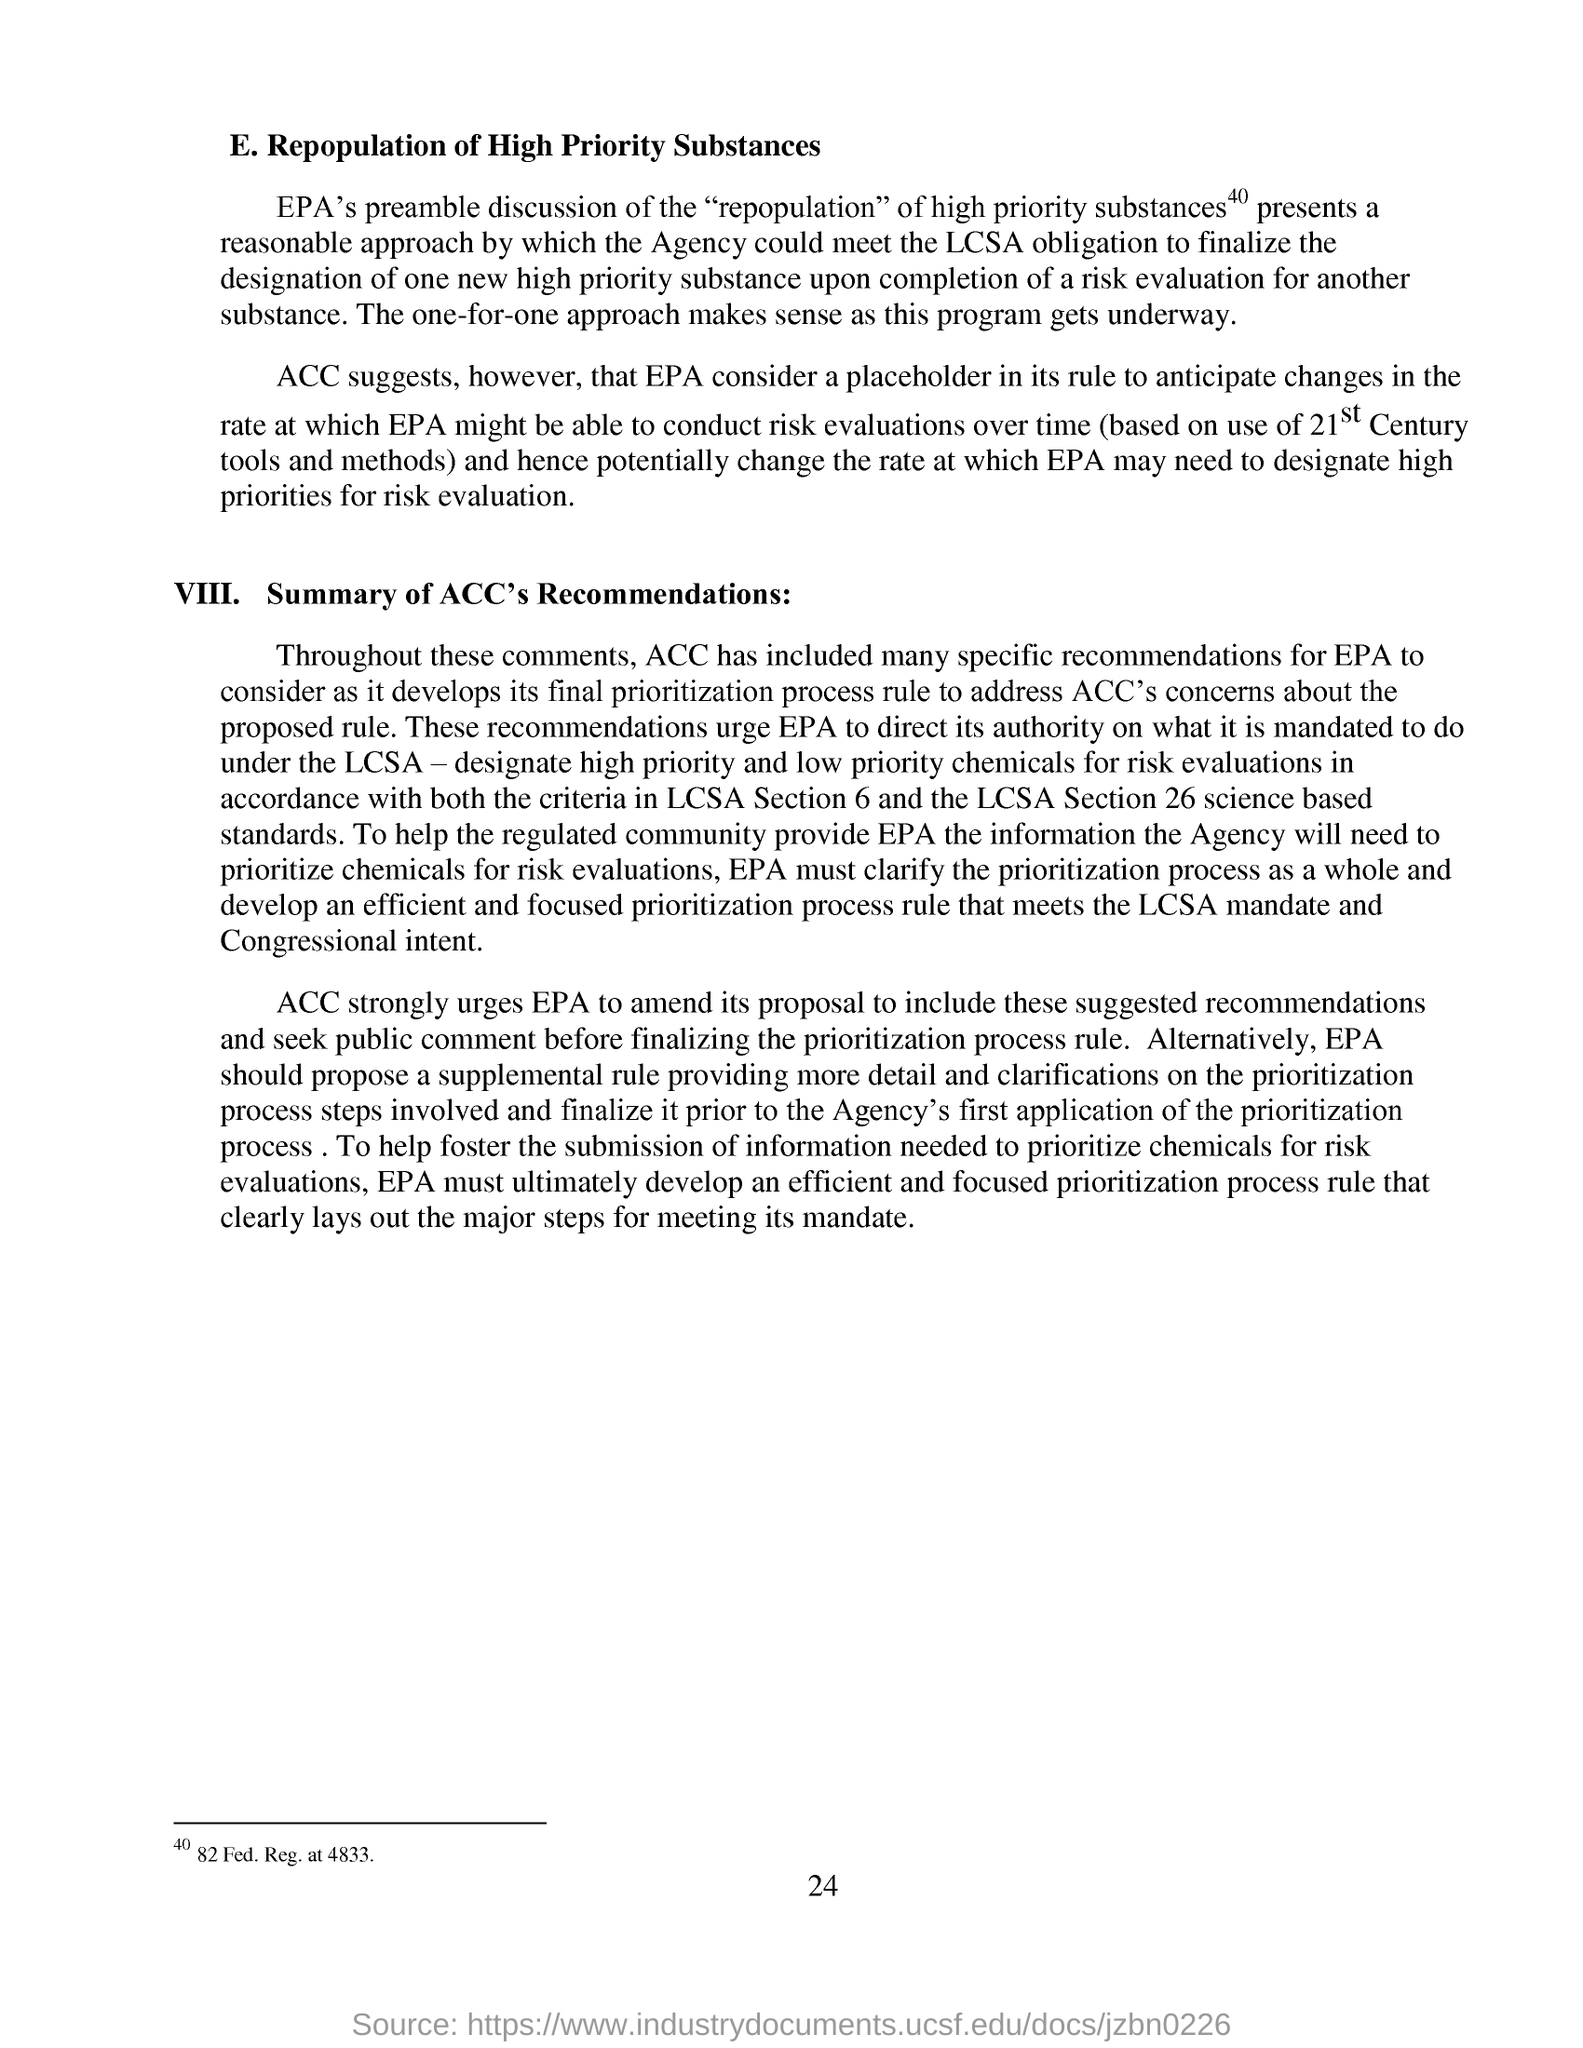What is the page no mentioned in this document?
Give a very brief answer. 24. EPA might consider risk evaluations over time based on which century's tools and methods?
Offer a terse response. 21st Century. What is the heading of the second paragraph?
Your answer should be very brief. Summary of ACC's Recommendations:. What is the heading of the first paragraph?
Offer a very short reply. E. Repopulation of High Priority Substances. 